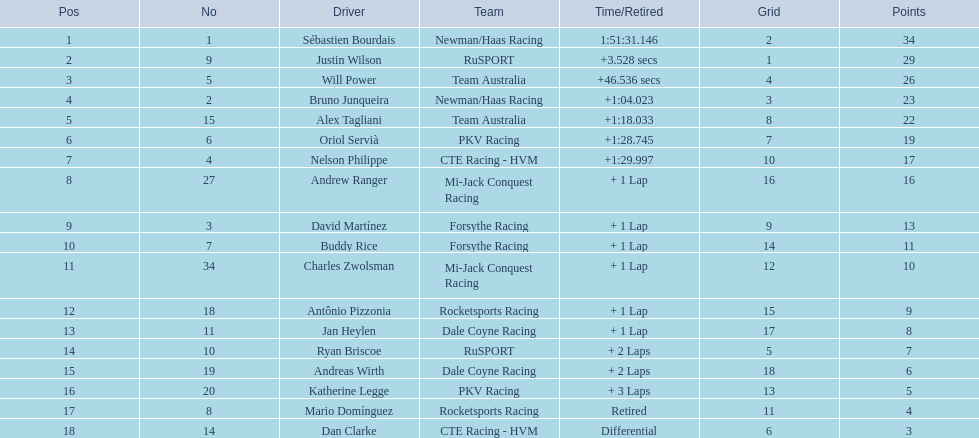Which people scored 29+ points? Sébastien Bourdais, Justin Wilson. Who scored higher? Sébastien Bourdais. 